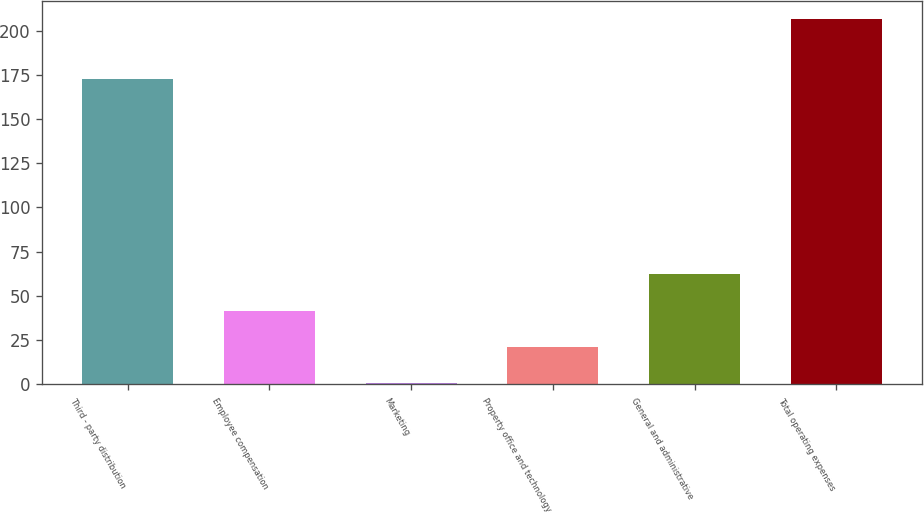Convert chart to OTSL. <chart><loc_0><loc_0><loc_500><loc_500><bar_chart><fcel>Third - party distribution<fcel>Employee compensation<fcel>Marketing<fcel>Property office and technology<fcel>General and administrative<fcel>Total operating expenses<nl><fcel>172.7<fcel>41.78<fcel>0.6<fcel>21.19<fcel>62.37<fcel>206.5<nl></chart> 